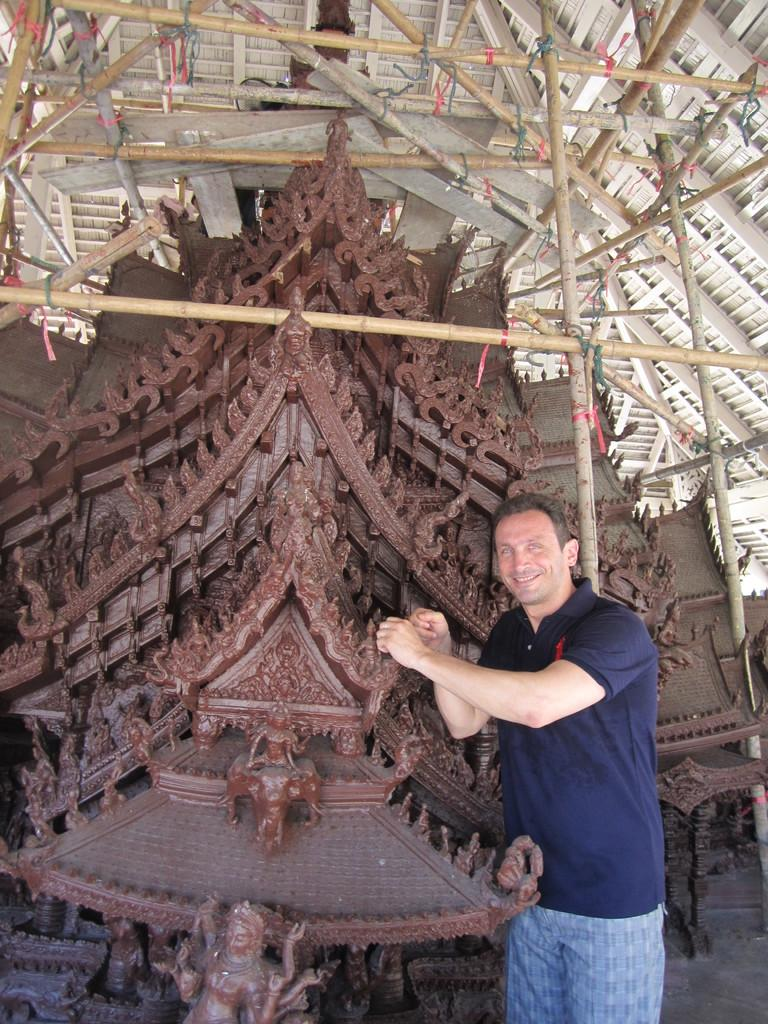What is the person in the image doing? The person is standing in the image and smiling. What type of architecture can be seen in the image? There is wooden architecture in the image. What is visible in the background of the image? The background of the image includes a roof and wooden poles. What type of needle is being used to sew the roof in the image? There is no needle present in the image, and the roof is not being sewn. 